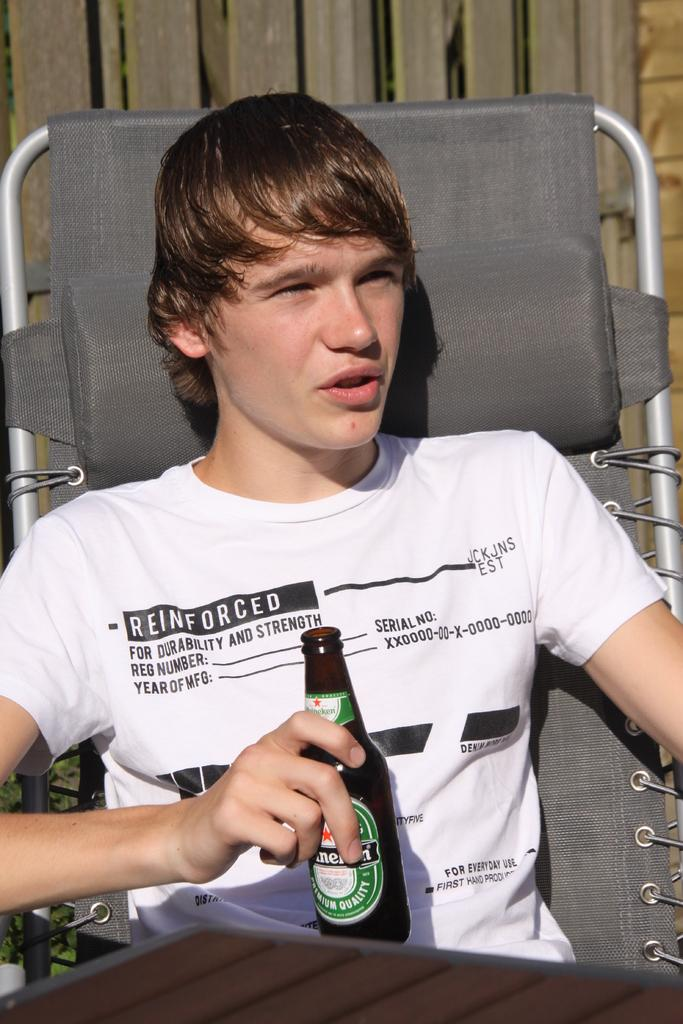What is the main subject of the image? There is a person in the image. What is the person doing in the image? The person is sitting on a chair. What object is the person holding in the image? The person is holding a bottle. How many legs does the dinosaur have in the image? There are no dinosaurs present in the image. What type of tooth is visible in the person's mouth in the image? The image does not show the person's teeth, so it is not possible to determine the type of tooth visible. 